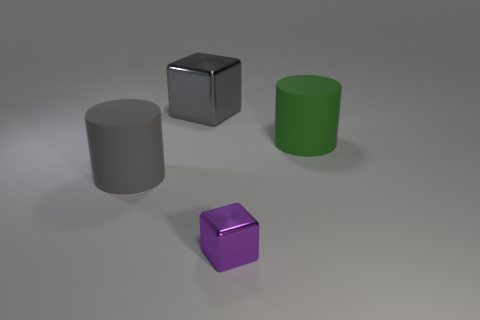Add 1 gray shiny objects. How many objects exist? 5 Subtract 1 gray blocks. How many objects are left? 3 Subtract all gray matte cylinders. Subtract all tiny metallic objects. How many objects are left? 2 Add 1 tiny purple cubes. How many tiny purple cubes are left? 2 Add 4 big gray matte objects. How many big gray matte objects exist? 5 